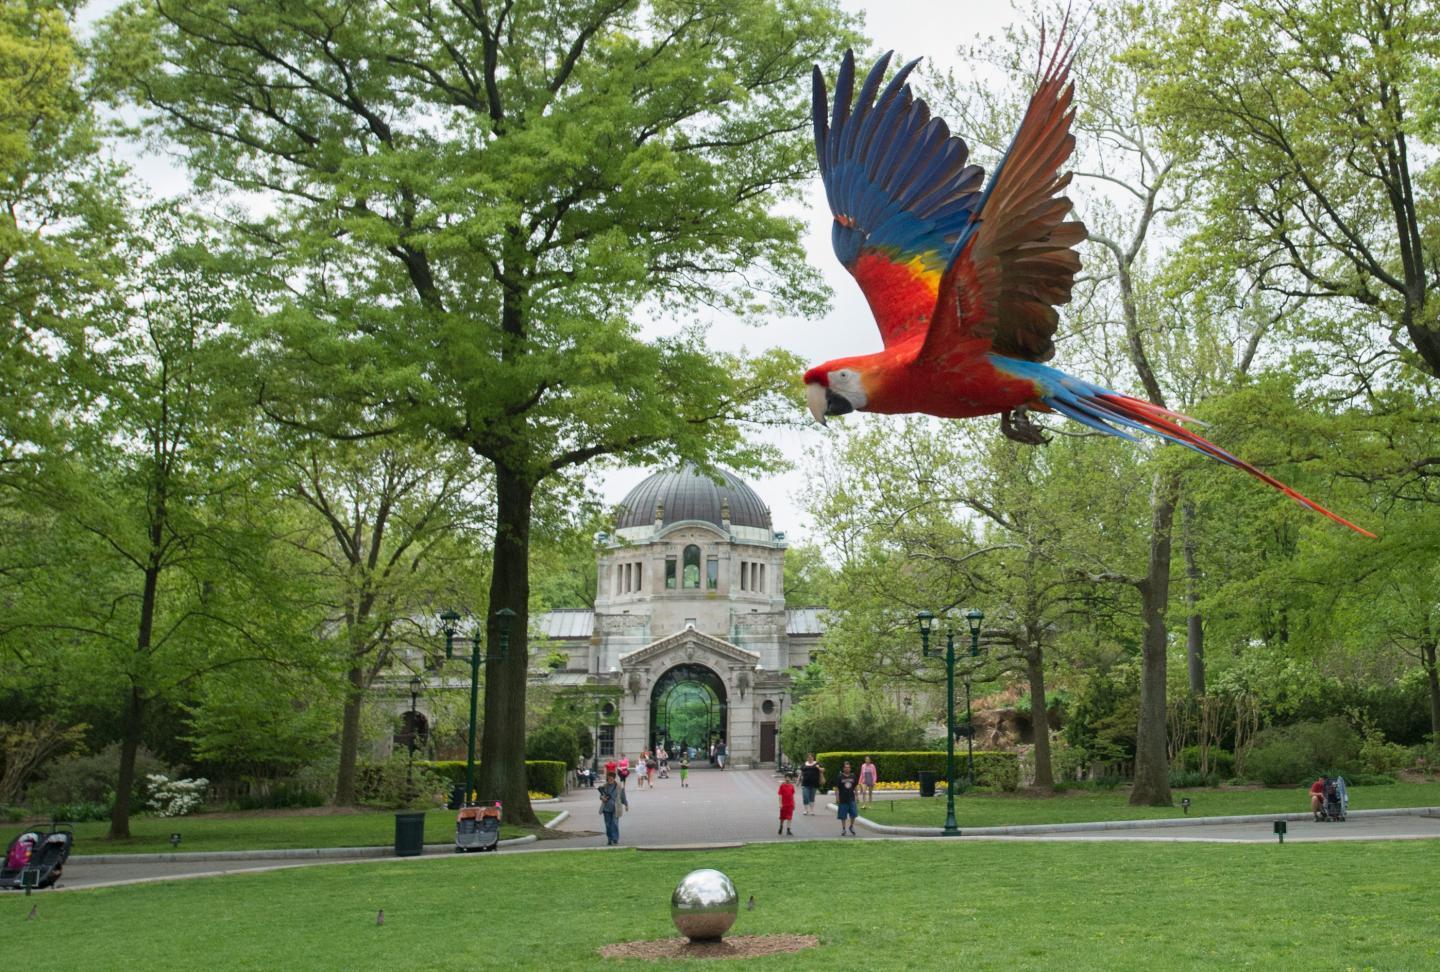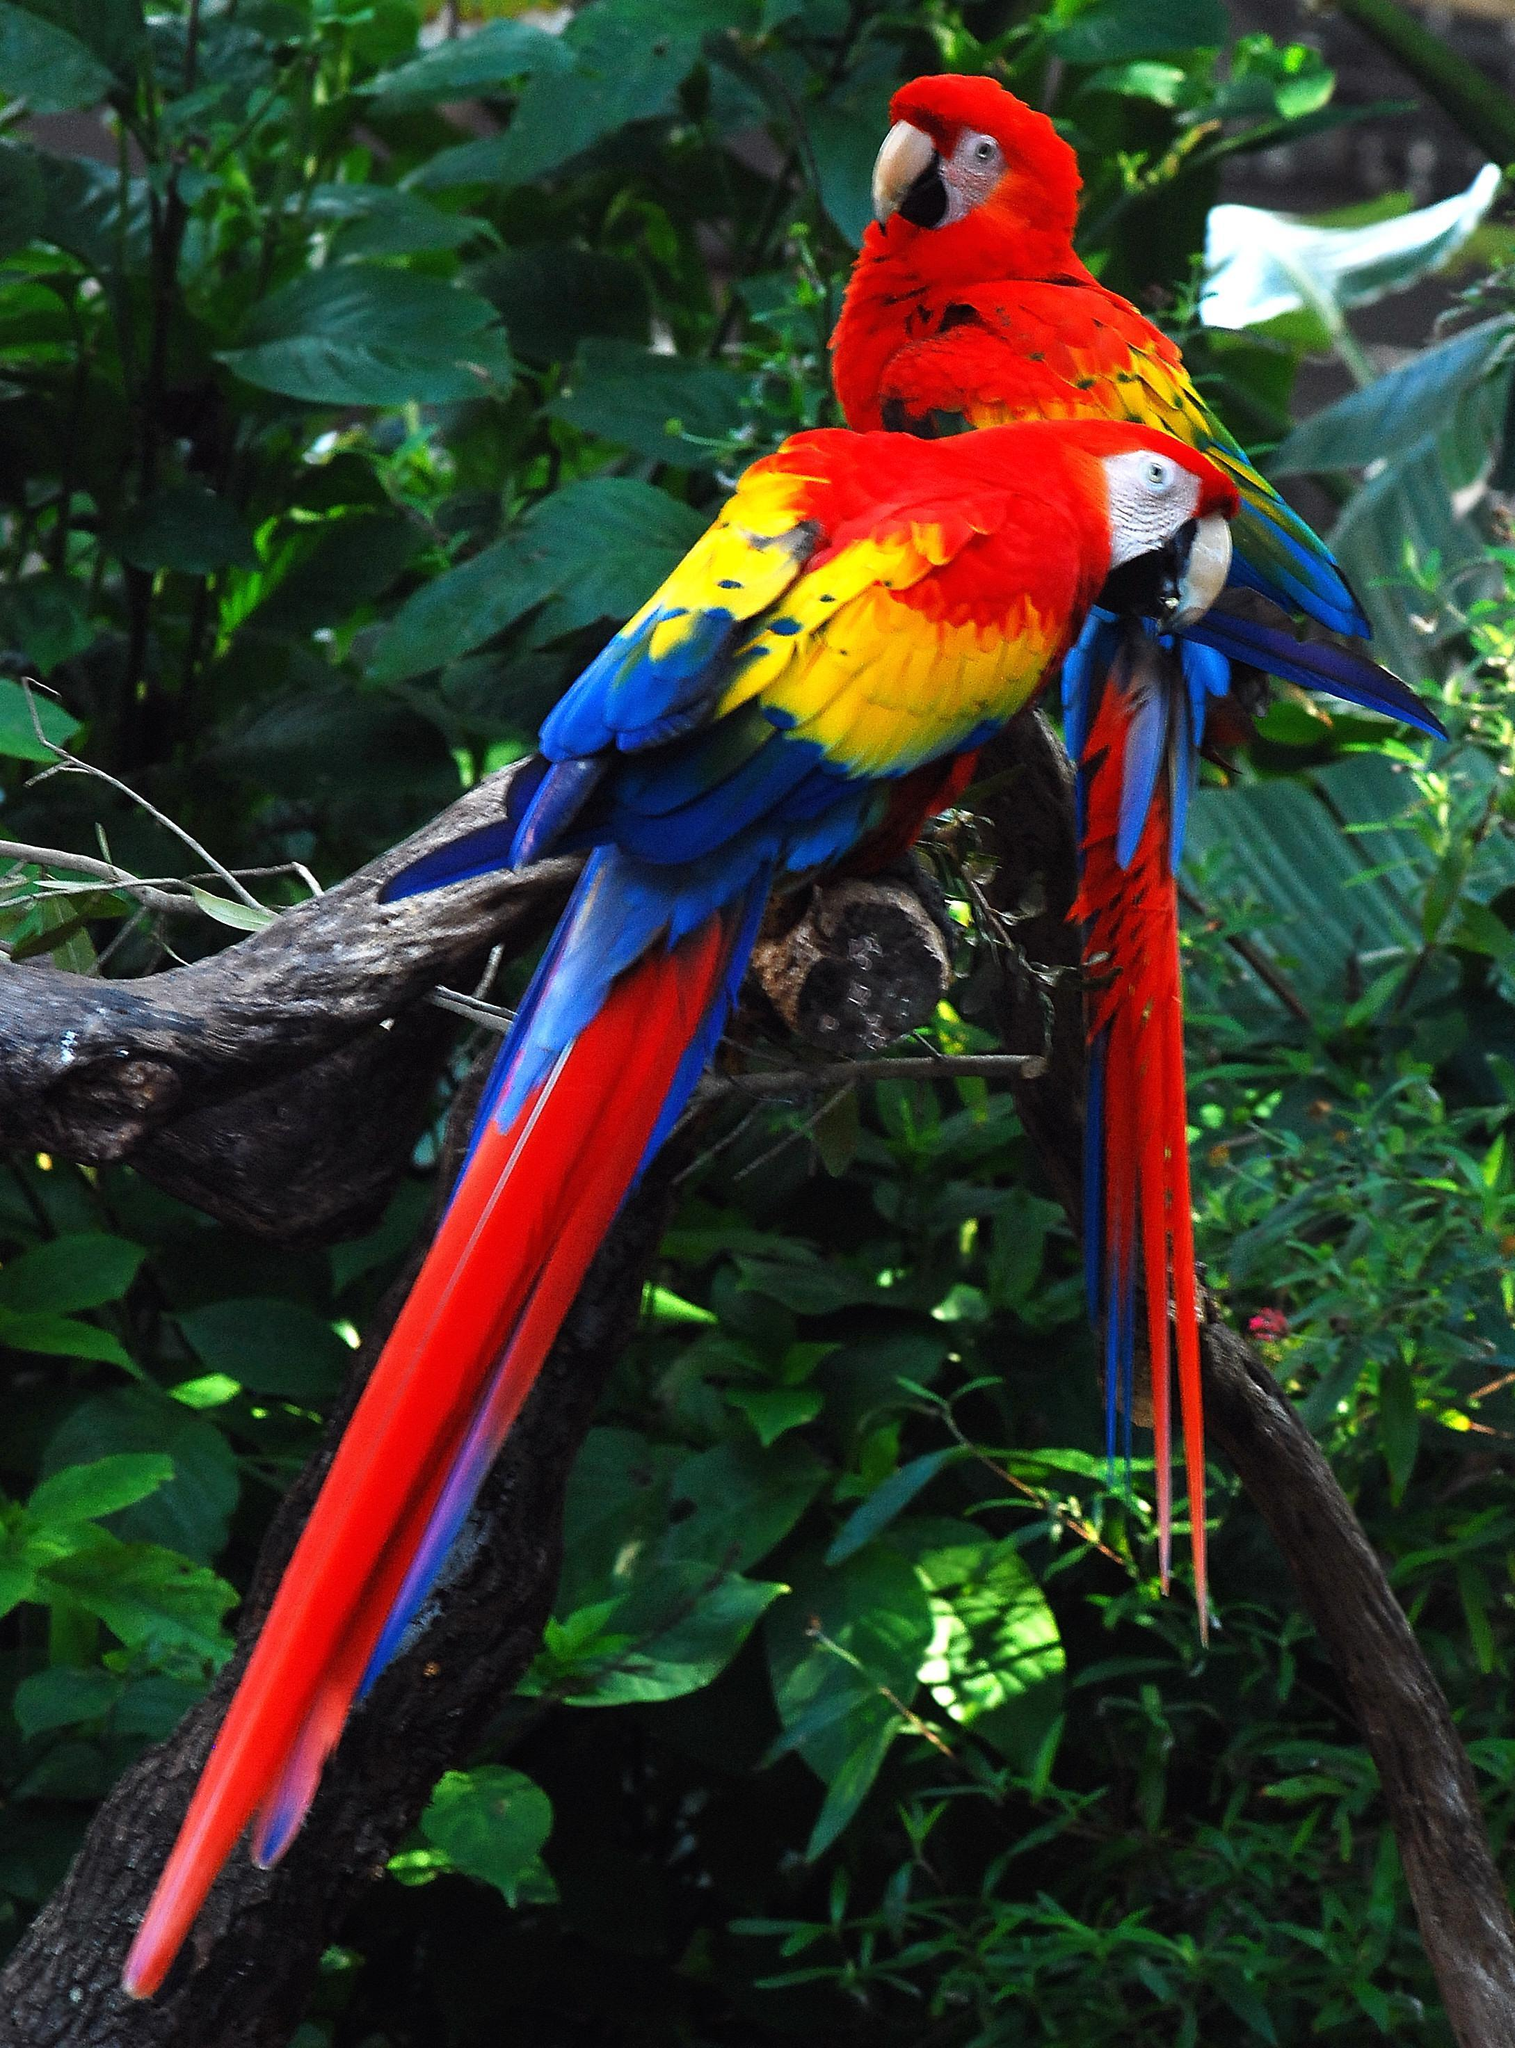The first image is the image on the left, the second image is the image on the right. Assess this claim about the two images: "There are exactly two birds in the image on the right.". Correct or not? Answer yes or no. Yes. The first image is the image on the left, the second image is the image on the right. Assess this claim about the two images: "In one image, two parrots are sitting together, but facing different directions.". Correct or not? Answer yes or no. Yes. The first image is the image on the left, the second image is the image on the right. Given the left and right images, does the statement "There are exactly two birds in the image on the right." hold true? Answer yes or no. Yes. 